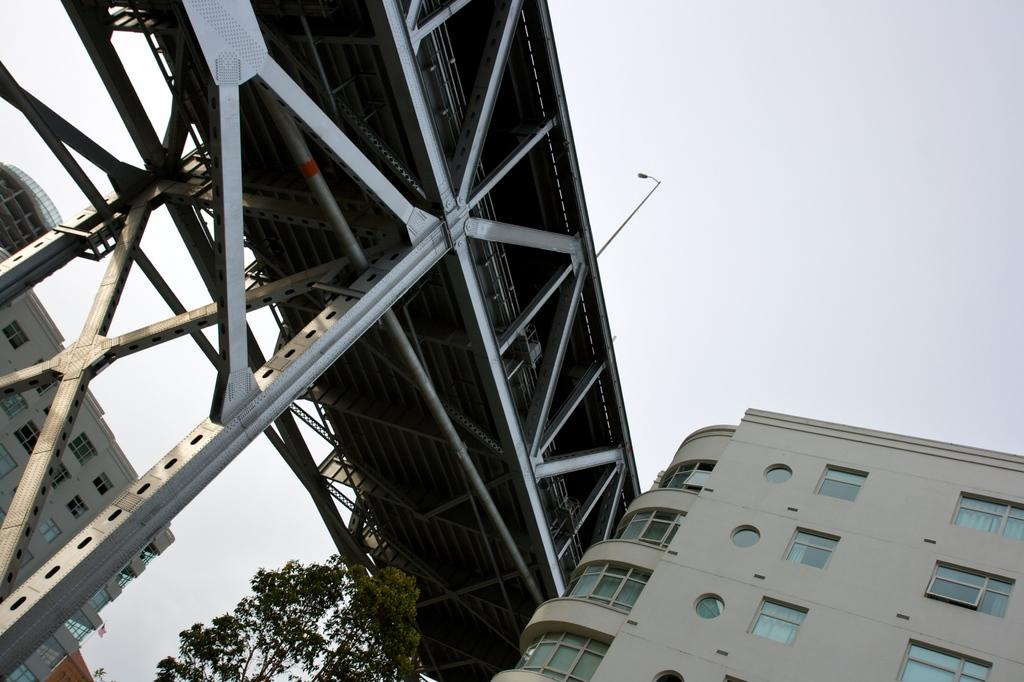What type of structures are visible in the image? There are buildings with windows in the image. What architectural feature can be seen connecting two areas in the image? There is a bridge in the image. What type of vegetation is present in the image? There is a tree in the image. What is visible above the structures and vegetation in the image? The sky is visible in the image. What type of thoughts are being exchanged between the lizards in the image? There are no lizards present in the image, so no thoughts can be exchanged between them. What type of battle is taking place in the image? There is no battle depicted in the image; it features buildings, a bridge, a tree, and the sky. 